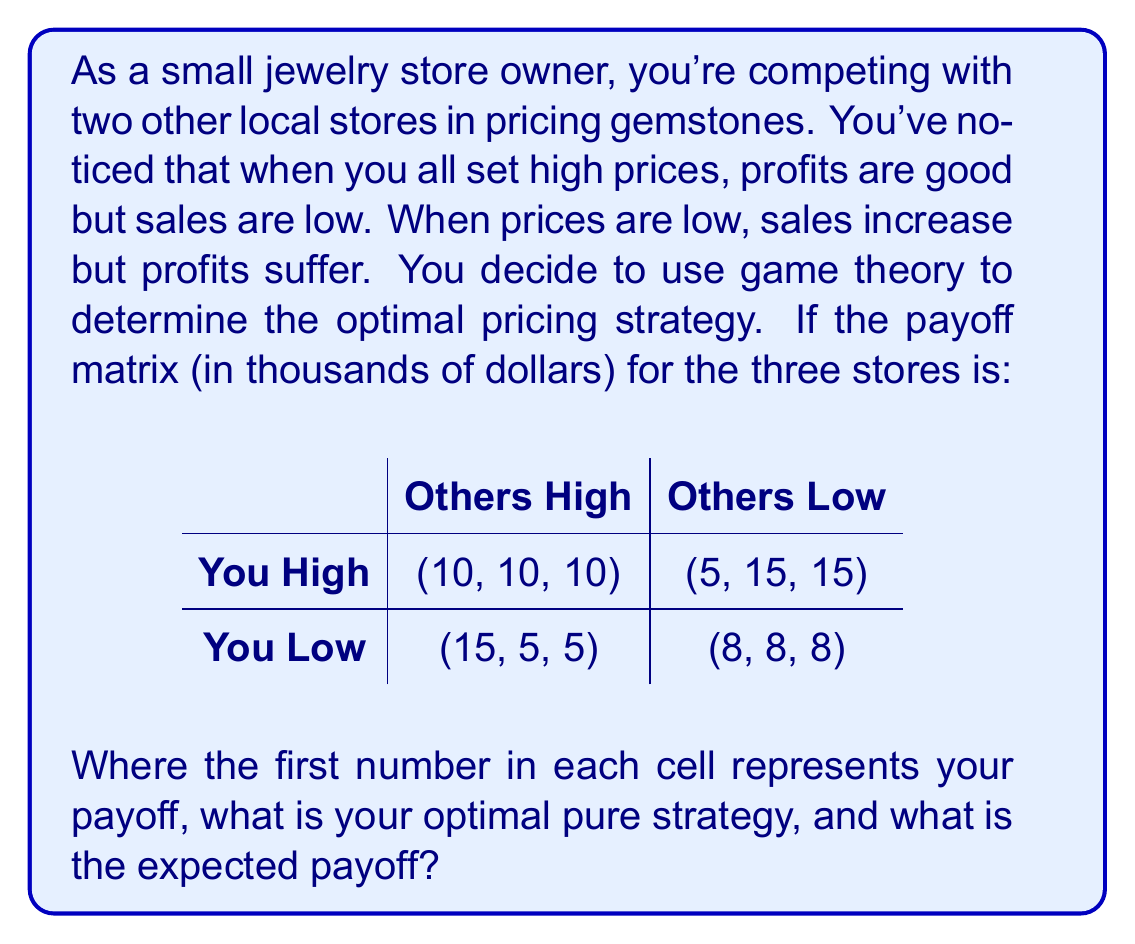Solve this math problem. To solve this problem, we need to analyze the game using the principles of game theory:

1) First, let's identify the dominant strategy, if any exists. A dominant strategy is one that gives a better payoff regardless of what the other players do.

2) When others price high:
   - If you price high, you get $10,000
   - If you price low, you get $15,000
   
3) When others price low:
   - If you price high, you get $5,000
   - If you price low, you get $8,000

4) We can see that pricing low always gives you a better payoff, regardless of what the others do. Therefore, pricing low is your dominant strategy.

5) In game theory, if all players have a dominant strategy, the outcome where all players play their dominant strategies is called the Nash equilibrium.

6) In this case, if all players (including your competitors) think rationally, they will also choose to price low, as it's the dominant strategy for everyone.

7) Therefore, the Nash equilibrium of this game is where all stores price low, resulting in a payoff of $8,000 for each store.

8) This outcome is also known as the "prisoner's dilemma" because if all stores could cooperate and agree to price high, they would all be better off (with $10,000 each). However, the incentive to undercut leads to a less optimal outcome for everyone.

Therefore, your optimal pure strategy is to price low, and the expected payoff at the Nash equilibrium is $8,000.
Answer: Optimal pure strategy: Price low
Expected payoff: $8,000 